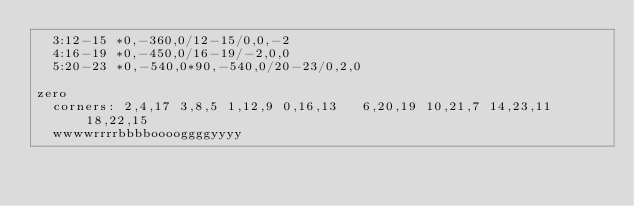Convert code to text. <code><loc_0><loc_0><loc_500><loc_500><_Crystal_>	3:12-15 *0,-360,0/12-15/0,0,-2
	4:16-19 *0,-450,0/16-19/-2,0,0
	5:20-23 *0,-540,0*90,-540,0/20-23/0,2,0

zero
	corners: 2,4,17 3,8,5 1,12,9 0,16,13   6,20,19 10,21,7 14,23,11 18,22,15
	wwwwrrrrbbbbooooggggyyyy
</code> 